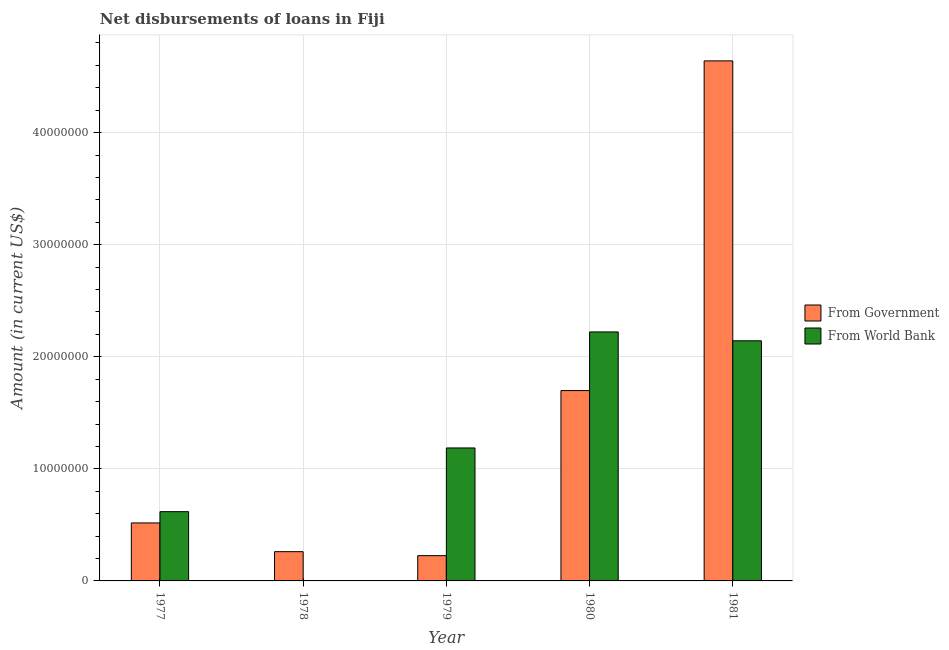How many different coloured bars are there?
Your response must be concise. 2. Are the number of bars per tick equal to the number of legend labels?
Keep it short and to the point. No. How many bars are there on the 1st tick from the left?
Your response must be concise. 2. What is the label of the 4th group of bars from the left?
Your answer should be compact. 1980. In how many cases, is the number of bars for a given year not equal to the number of legend labels?
Your answer should be compact. 1. What is the net disbursements of loan from world bank in 1980?
Keep it short and to the point. 2.22e+07. Across all years, what is the maximum net disbursements of loan from world bank?
Ensure brevity in your answer.  2.22e+07. Across all years, what is the minimum net disbursements of loan from government?
Make the answer very short. 2.26e+06. In which year was the net disbursements of loan from world bank maximum?
Your response must be concise. 1980. What is the total net disbursements of loan from world bank in the graph?
Make the answer very short. 6.17e+07. What is the difference between the net disbursements of loan from world bank in 1977 and that in 1981?
Offer a very short reply. -1.52e+07. What is the difference between the net disbursements of loan from world bank in 1978 and the net disbursements of loan from government in 1981?
Keep it short and to the point. -2.14e+07. What is the average net disbursements of loan from government per year?
Give a very brief answer. 1.47e+07. In the year 1978, what is the difference between the net disbursements of loan from government and net disbursements of loan from world bank?
Give a very brief answer. 0. In how many years, is the net disbursements of loan from government greater than 42000000 US$?
Offer a terse response. 1. What is the ratio of the net disbursements of loan from world bank in 1977 to that in 1981?
Your response must be concise. 0.29. Is the net disbursements of loan from government in 1978 less than that in 1981?
Provide a short and direct response. Yes. What is the difference between the highest and the second highest net disbursements of loan from government?
Provide a short and direct response. 2.94e+07. What is the difference between the highest and the lowest net disbursements of loan from world bank?
Offer a terse response. 2.22e+07. How many bars are there?
Your answer should be compact. 9. What is the difference between two consecutive major ticks on the Y-axis?
Give a very brief answer. 1.00e+07. Does the graph contain any zero values?
Offer a terse response. Yes. Does the graph contain grids?
Make the answer very short. Yes. How many legend labels are there?
Offer a very short reply. 2. How are the legend labels stacked?
Your answer should be compact. Vertical. What is the title of the graph?
Provide a succinct answer. Net disbursements of loans in Fiji. Does "Investments" appear as one of the legend labels in the graph?
Provide a short and direct response. No. What is the Amount (in current US$) of From Government in 1977?
Your answer should be very brief. 5.18e+06. What is the Amount (in current US$) of From World Bank in 1977?
Your response must be concise. 6.18e+06. What is the Amount (in current US$) in From Government in 1978?
Provide a succinct answer. 2.61e+06. What is the Amount (in current US$) of From Government in 1979?
Keep it short and to the point. 2.26e+06. What is the Amount (in current US$) of From World Bank in 1979?
Offer a very short reply. 1.19e+07. What is the Amount (in current US$) in From Government in 1980?
Your answer should be very brief. 1.70e+07. What is the Amount (in current US$) in From World Bank in 1980?
Offer a very short reply. 2.22e+07. What is the Amount (in current US$) in From Government in 1981?
Provide a succinct answer. 4.64e+07. What is the Amount (in current US$) in From World Bank in 1981?
Your response must be concise. 2.14e+07. Across all years, what is the maximum Amount (in current US$) of From Government?
Ensure brevity in your answer.  4.64e+07. Across all years, what is the maximum Amount (in current US$) of From World Bank?
Give a very brief answer. 2.22e+07. Across all years, what is the minimum Amount (in current US$) of From Government?
Keep it short and to the point. 2.26e+06. What is the total Amount (in current US$) in From Government in the graph?
Provide a short and direct response. 7.34e+07. What is the total Amount (in current US$) of From World Bank in the graph?
Ensure brevity in your answer.  6.17e+07. What is the difference between the Amount (in current US$) in From Government in 1977 and that in 1978?
Offer a terse response. 2.56e+06. What is the difference between the Amount (in current US$) of From Government in 1977 and that in 1979?
Make the answer very short. 2.92e+06. What is the difference between the Amount (in current US$) of From World Bank in 1977 and that in 1979?
Provide a short and direct response. -5.68e+06. What is the difference between the Amount (in current US$) in From Government in 1977 and that in 1980?
Give a very brief answer. -1.18e+07. What is the difference between the Amount (in current US$) in From World Bank in 1977 and that in 1980?
Ensure brevity in your answer.  -1.60e+07. What is the difference between the Amount (in current US$) of From Government in 1977 and that in 1981?
Offer a very short reply. -4.12e+07. What is the difference between the Amount (in current US$) of From World Bank in 1977 and that in 1981?
Ensure brevity in your answer.  -1.52e+07. What is the difference between the Amount (in current US$) in From Government in 1978 and that in 1979?
Your answer should be compact. 3.56e+05. What is the difference between the Amount (in current US$) of From Government in 1978 and that in 1980?
Keep it short and to the point. -1.44e+07. What is the difference between the Amount (in current US$) of From Government in 1978 and that in 1981?
Your response must be concise. -4.38e+07. What is the difference between the Amount (in current US$) in From Government in 1979 and that in 1980?
Offer a terse response. -1.47e+07. What is the difference between the Amount (in current US$) of From World Bank in 1979 and that in 1980?
Give a very brief answer. -1.04e+07. What is the difference between the Amount (in current US$) of From Government in 1979 and that in 1981?
Give a very brief answer. -4.41e+07. What is the difference between the Amount (in current US$) in From World Bank in 1979 and that in 1981?
Make the answer very short. -9.56e+06. What is the difference between the Amount (in current US$) in From Government in 1980 and that in 1981?
Your answer should be very brief. -2.94e+07. What is the difference between the Amount (in current US$) of From World Bank in 1980 and that in 1981?
Offer a terse response. 7.92e+05. What is the difference between the Amount (in current US$) of From Government in 1977 and the Amount (in current US$) of From World Bank in 1979?
Your answer should be very brief. -6.69e+06. What is the difference between the Amount (in current US$) in From Government in 1977 and the Amount (in current US$) in From World Bank in 1980?
Make the answer very short. -1.70e+07. What is the difference between the Amount (in current US$) in From Government in 1977 and the Amount (in current US$) in From World Bank in 1981?
Your answer should be very brief. -1.62e+07. What is the difference between the Amount (in current US$) in From Government in 1978 and the Amount (in current US$) in From World Bank in 1979?
Your answer should be compact. -9.25e+06. What is the difference between the Amount (in current US$) of From Government in 1978 and the Amount (in current US$) of From World Bank in 1980?
Provide a short and direct response. -1.96e+07. What is the difference between the Amount (in current US$) of From Government in 1978 and the Amount (in current US$) of From World Bank in 1981?
Offer a terse response. -1.88e+07. What is the difference between the Amount (in current US$) in From Government in 1979 and the Amount (in current US$) in From World Bank in 1980?
Ensure brevity in your answer.  -2.00e+07. What is the difference between the Amount (in current US$) of From Government in 1979 and the Amount (in current US$) of From World Bank in 1981?
Give a very brief answer. -1.92e+07. What is the difference between the Amount (in current US$) in From Government in 1980 and the Amount (in current US$) in From World Bank in 1981?
Make the answer very short. -4.44e+06. What is the average Amount (in current US$) of From Government per year?
Your response must be concise. 1.47e+07. What is the average Amount (in current US$) in From World Bank per year?
Keep it short and to the point. 1.23e+07. In the year 1977, what is the difference between the Amount (in current US$) of From Government and Amount (in current US$) of From World Bank?
Provide a succinct answer. -1.00e+06. In the year 1979, what is the difference between the Amount (in current US$) of From Government and Amount (in current US$) of From World Bank?
Offer a very short reply. -9.61e+06. In the year 1980, what is the difference between the Amount (in current US$) of From Government and Amount (in current US$) of From World Bank?
Your answer should be very brief. -5.23e+06. In the year 1981, what is the difference between the Amount (in current US$) of From Government and Amount (in current US$) of From World Bank?
Keep it short and to the point. 2.50e+07. What is the ratio of the Amount (in current US$) in From Government in 1977 to that in 1978?
Your response must be concise. 1.98. What is the ratio of the Amount (in current US$) of From Government in 1977 to that in 1979?
Your answer should be very brief. 2.29. What is the ratio of the Amount (in current US$) of From World Bank in 1977 to that in 1979?
Offer a very short reply. 0.52. What is the ratio of the Amount (in current US$) in From Government in 1977 to that in 1980?
Give a very brief answer. 0.3. What is the ratio of the Amount (in current US$) of From World Bank in 1977 to that in 1980?
Your answer should be compact. 0.28. What is the ratio of the Amount (in current US$) of From Government in 1977 to that in 1981?
Your answer should be compact. 0.11. What is the ratio of the Amount (in current US$) in From World Bank in 1977 to that in 1981?
Ensure brevity in your answer.  0.29. What is the ratio of the Amount (in current US$) in From Government in 1978 to that in 1979?
Provide a short and direct response. 1.16. What is the ratio of the Amount (in current US$) of From Government in 1978 to that in 1980?
Your answer should be compact. 0.15. What is the ratio of the Amount (in current US$) in From Government in 1978 to that in 1981?
Provide a short and direct response. 0.06. What is the ratio of the Amount (in current US$) in From Government in 1979 to that in 1980?
Keep it short and to the point. 0.13. What is the ratio of the Amount (in current US$) in From World Bank in 1979 to that in 1980?
Your response must be concise. 0.53. What is the ratio of the Amount (in current US$) in From Government in 1979 to that in 1981?
Ensure brevity in your answer.  0.05. What is the ratio of the Amount (in current US$) in From World Bank in 1979 to that in 1981?
Offer a terse response. 0.55. What is the ratio of the Amount (in current US$) in From Government in 1980 to that in 1981?
Keep it short and to the point. 0.37. What is the ratio of the Amount (in current US$) of From World Bank in 1980 to that in 1981?
Give a very brief answer. 1.04. What is the difference between the highest and the second highest Amount (in current US$) in From Government?
Make the answer very short. 2.94e+07. What is the difference between the highest and the second highest Amount (in current US$) of From World Bank?
Ensure brevity in your answer.  7.92e+05. What is the difference between the highest and the lowest Amount (in current US$) in From Government?
Your answer should be compact. 4.41e+07. What is the difference between the highest and the lowest Amount (in current US$) in From World Bank?
Offer a terse response. 2.22e+07. 